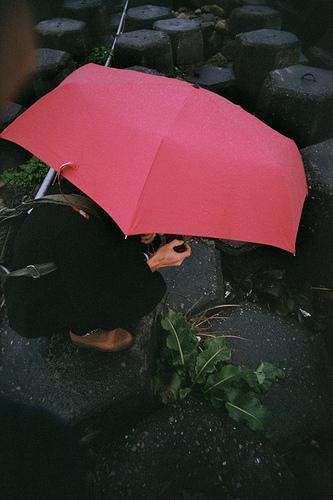How many people in this picture?
Give a very brief answer. 1. 